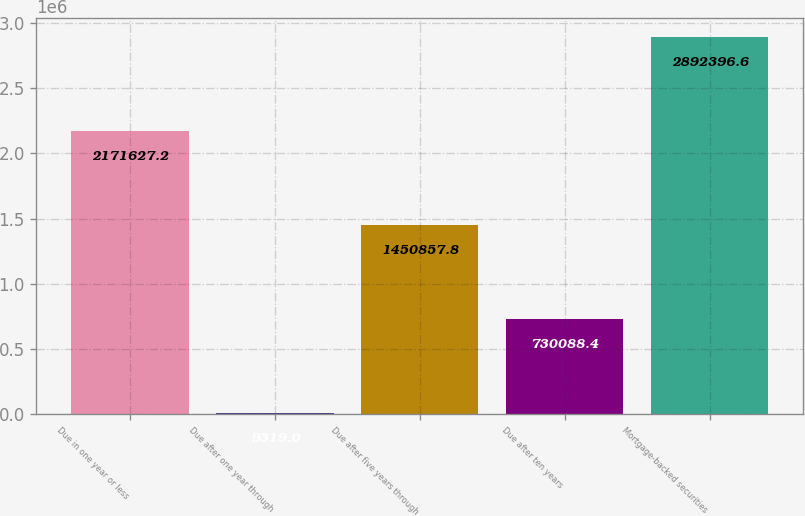Convert chart to OTSL. <chart><loc_0><loc_0><loc_500><loc_500><bar_chart><fcel>Due in one year or less<fcel>Due after one year through<fcel>Due after five years through<fcel>Due after ten years<fcel>Mortgage-backed securities<nl><fcel>2.17163e+06<fcel>9319<fcel>1.45086e+06<fcel>730088<fcel>2.8924e+06<nl></chart> 